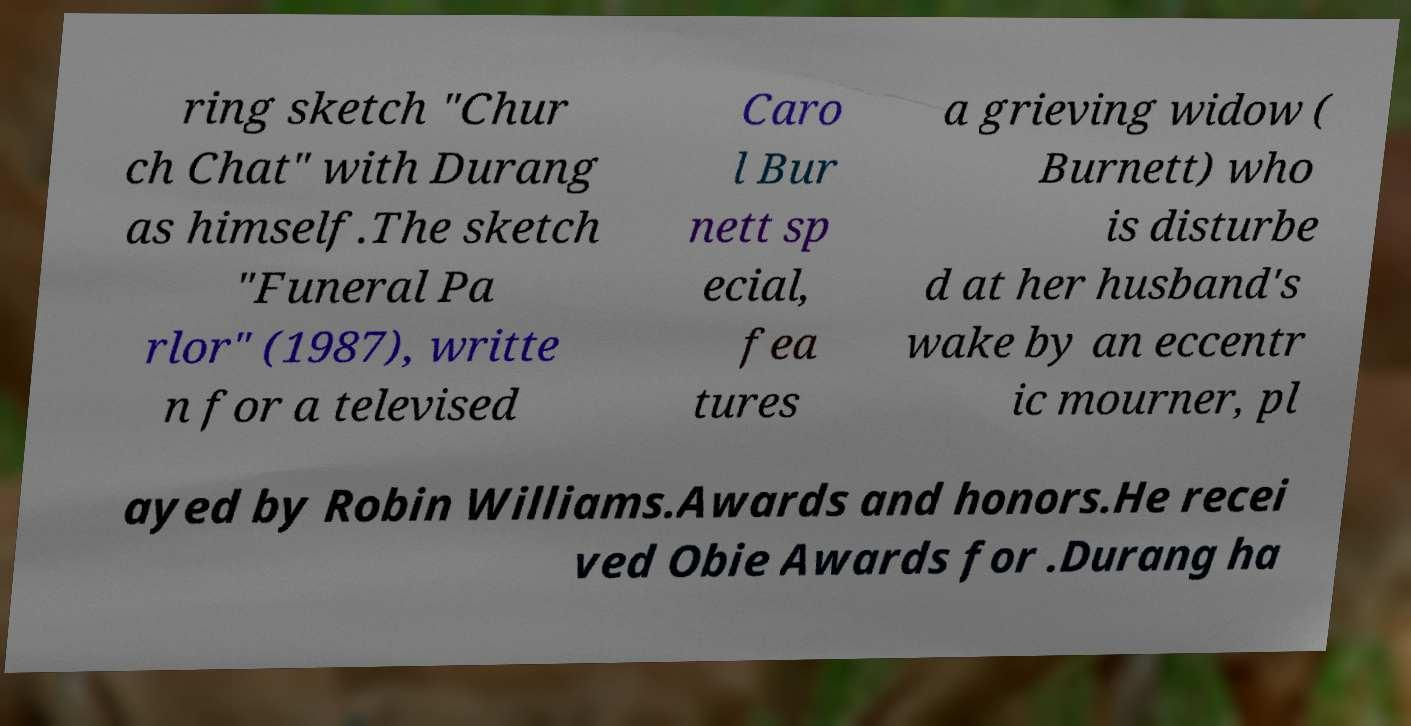Could you extract and type out the text from this image? ring sketch "Chur ch Chat" with Durang as himself.The sketch "Funeral Pa rlor" (1987), writte n for a televised Caro l Bur nett sp ecial, fea tures a grieving widow ( Burnett) who is disturbe d at her husband's wake by an eccentr ic mourner, pl ayed by Robin Williams.Awards and honors.He recei ved Obie Awards for .Durang ha 